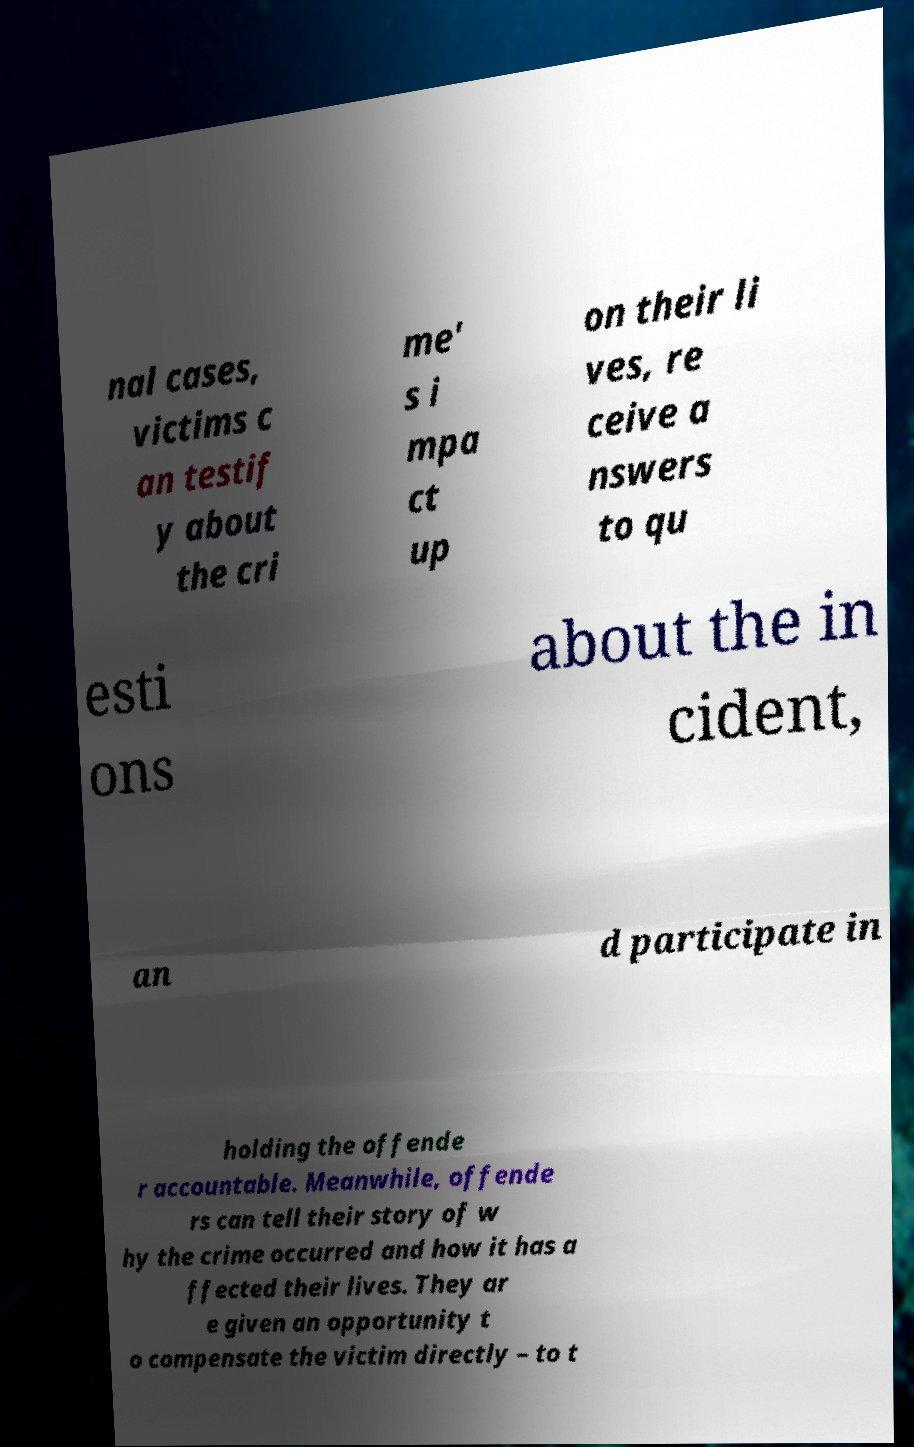For documentation purposes, I need the text within this image transcribed. Could you provide that? nal cases, victims c an testif y about the cri me' s i mpa ct up on their li ves, re ceive a nswers to qu esti ons about the in cident, an d participate in holding the offende r accountable. Meanwhile, offende rs can tell their story of w hy the crime occurred and how it has a ffected their lives. They ar e given an opportunity t o compensate the victim directly – to t 